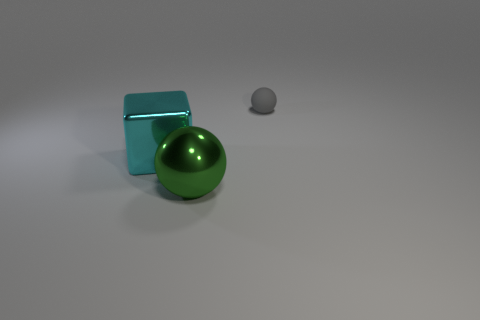Add 1 cyan shiny blocks. How many objects exist? 4 Subtract all balls. How many objects are left? 1 Subtract all blocks. Subtract all big spheres. How many objects are left? 1 Add 3 big metal balls. How many big metal balls are left? 4 Add 1 large blue rubber cubes. How many large blue rubber cubes exist? 1 Subtract 0 red cubes. How many objects are left? 3 